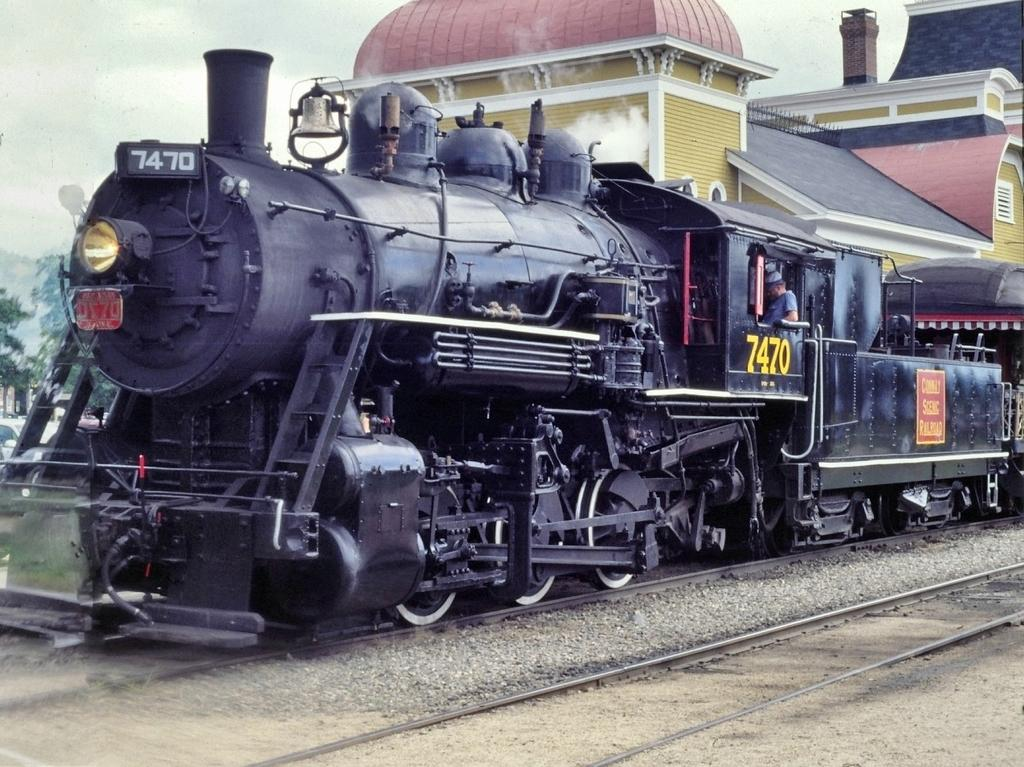What type of vehicle is in the picture? There is a steam engine in the picture. Where is the steam engine located? The steam engine is on railway tracks. Is there anyone inside the steam engine? Yes, there is a person inside the steam engine. What type of box is being used to store the steam in the image? There is no box present in the image for storing steam. The steam is produced by the steam engine itself. 